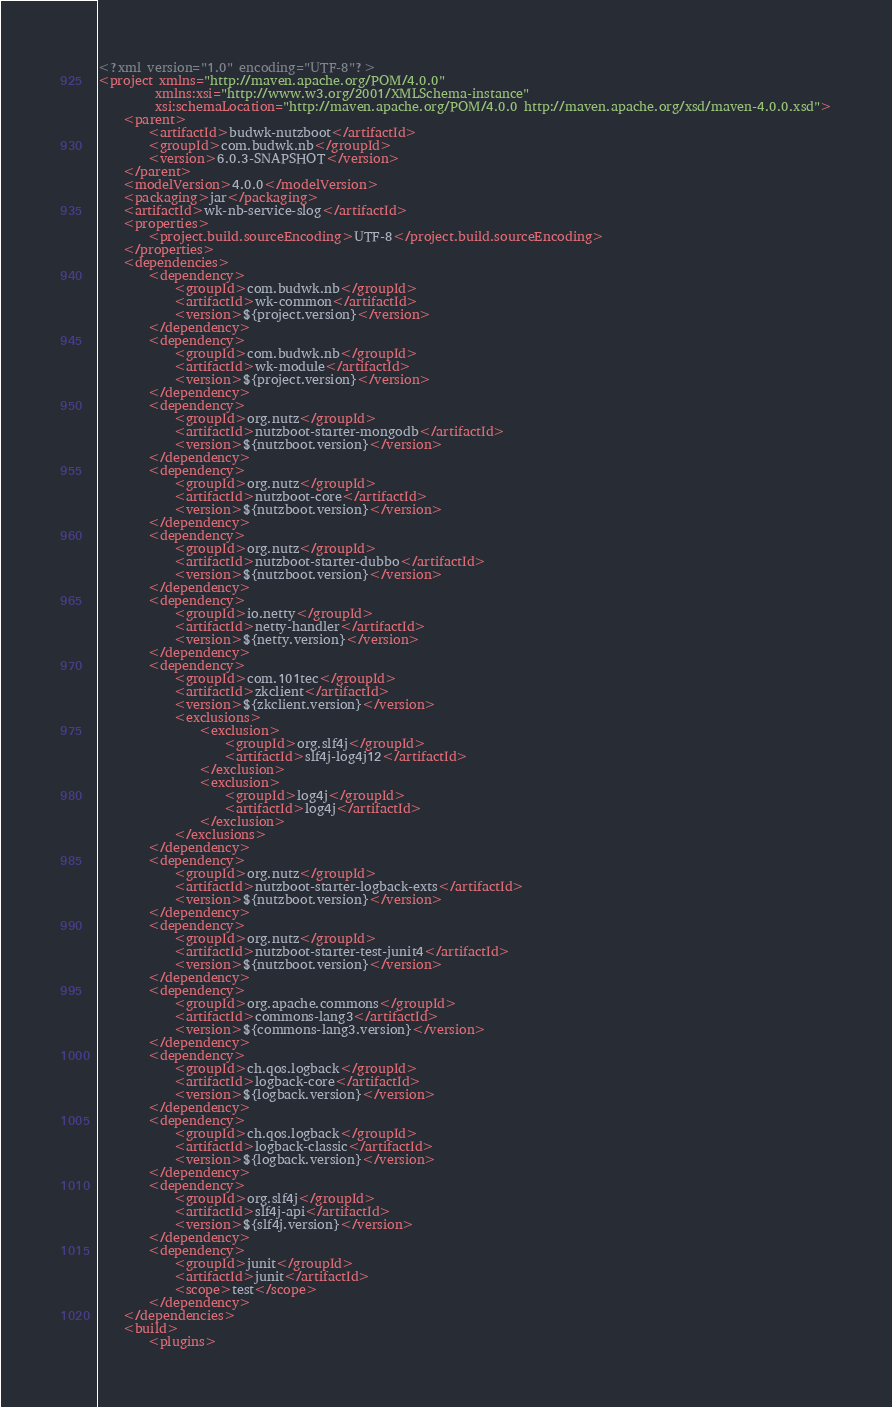<code> <loc_0><loc_0><loc_500><loc_500><_XML_><?xml version="1.0" encoding="UTF-8"?>
<project xmlns="http://maven.apache.org/POM/4.0.0"
         xmlns:xsi="http://www.w3.org/2001/XMLSchema-instance"
         xsi:schemaLocation="http://maven.apache.org/POM/4.0.0 http://maven.apache.org/xsd/maven-4.0.0.xsd">
    <parent>
        <artifactId>budwk-nutzboot</artifactId>
        <groupId>com.budwk.nb</groupId>
        <version>6.0.3-SNAPSHOT</version>
    </parent>
    <modelVersion>4.0.0</modelVersion>
    <packaging>jar</packaging>
    <artifactId>wk-nb-service-slog</artifactId>
    <properties>
        <project.build.sourceEncoding>UTF-8</project.build.sourceEncoding>
    </properties>
    <dependencies>
        <dependency>
            <groupId>com.budwk.nb</groupId>
            <artifactId>wk-common</artifactId>
            <version>${project.version}</version>
        </dependency>
        <dependency>
            <groupId>com.budwk.nb</groupId>
            <artifactId>wk-module</artifactId>
            <version>${project.version}</version>
        </dependency>
        <dependency>
            <groupId>org.nutz</groupId>
            <artifactId>nutzboot-starter-mongodb</artifactId>
            <version>${nutzboot.version}</version>
        </dependency>
        <dependency>
            <groupId>org.nutz</groupId>
            <artifactId>nutzboot-core</artifactId>
            <version>${nutzboot.version}</version>
        </dependency>
        <dependency>
            <groupId>org.nutz</groupId>
            <artifactId>nutzboot-starter-dubbo</artifactId>
            <version>${nutzboot.version}</version>
        </dependency>
        <dependency>
            <groupId>io.netty</groupId>
            <artifactId>netty-handler</artifactId>
            <version>${netty.version}</version>
        </dependency>
        <dependency>
            <groupId>com.101tec</groupId>
            <artifactId>zkclient</artifactId>
            <version>${zkclient.version}</version>
            <exclusions>
                <exclusion>
                    <groupId>org.slf4j</groupId>
                    <artifactId>slf4j-log4j12</artifactId>
                </exclusion>
                <exclusion>
                    <groupId>log4j</groupId>
                    <artifactId>log4j</artifactId>
                </exclusion>
            </exclusions>
        </dependency>
        <dependency>
            <groupId>org.nutz</groupId>
            <artifactId>nutzboot-starter-logback-exts</artifactId>
            <version>${nutzboot.version}</version>
        </dependency>
        <dependency>
            <groupId>org.nutz</groupId>
            <artifactId>nutzboot-starter-test-junit4</artifactId>
            <version>${nutzboot.version}</version>
        </dependency>
        <dependency>
            <groupId>org.apache.commons</groupId>
            <artifactId>commons-lang3</artifactId>
            <version>${commons-lang3.version}</version>
        </dependency>
        <dependency>
            <groupId>ch.qos.logback</groupId>
            <artifactId>logback-core</artifactId>
            <version>${logback.version}</version>
        </dependency>
        <dependency>
            <groupId>ch.qos.logback</groupId>
            <artifactId>logback-classic</artifactId>
            <version>${logback.version}</version>
        </dependency>
        <dependency>
            <groupId>org.slf4j</groupId>
            <artifactId>slf4j-api</artifactId>
            <version>${slf4j.version}</version>
        </dependency>
        <dependency>
            <groupId>junit</groupId>
            <artifactId>junit</artifactId>
            <scope>test</scope>
        </dependency>
    </dependencies>
    <build>
        <plugins></code> 